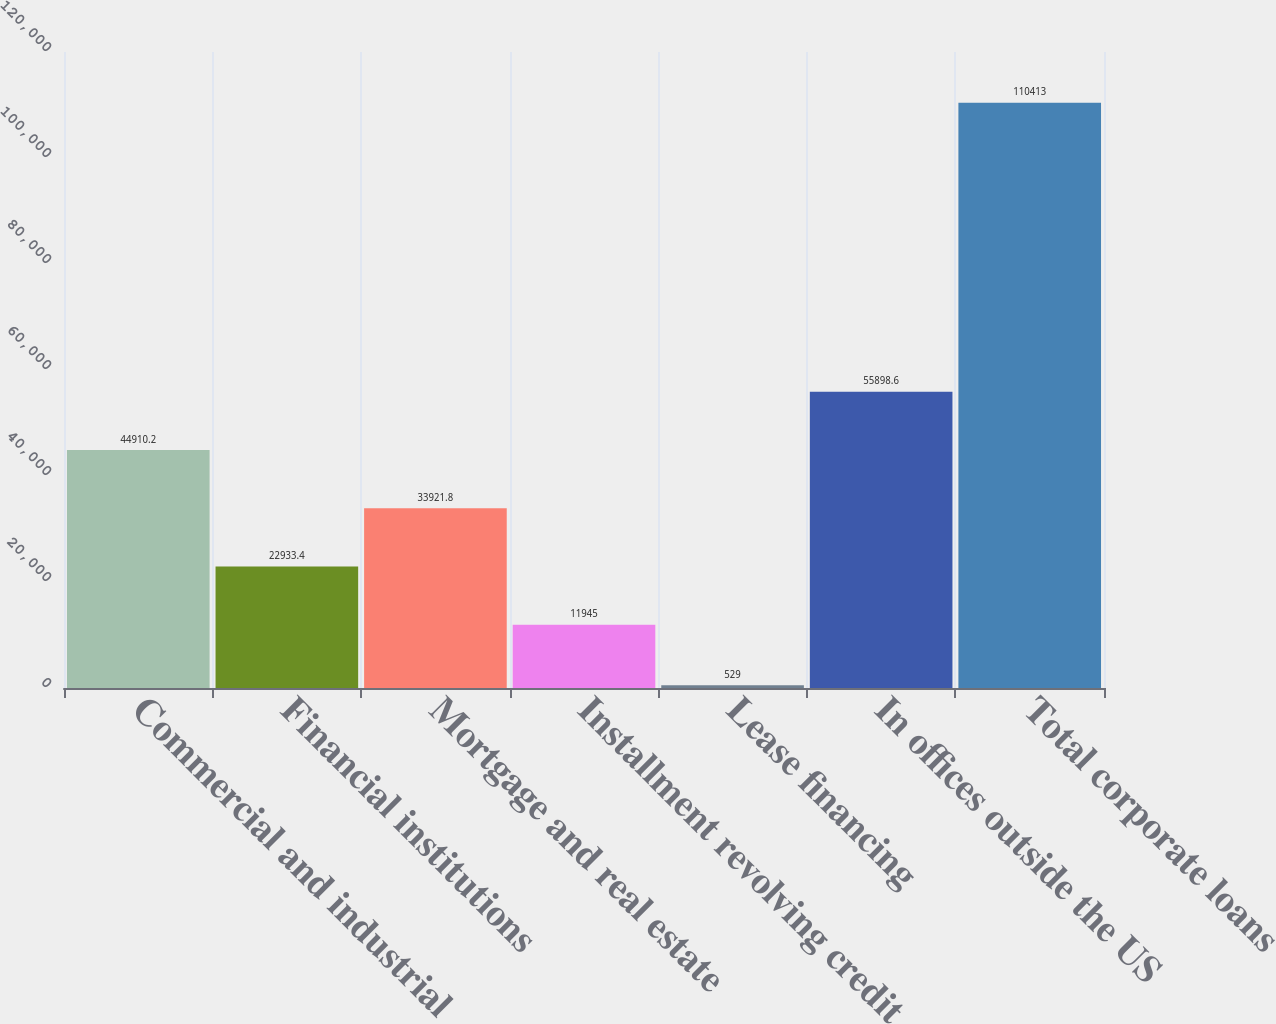<chart> <loc_0><loc_0><loc_500><loc_500><bar_chart><fcel>Commercial and industrial<fcel>Financial institutions<fcel>Mortgage and real estate<fcel>Installment revolving credit<fcel>Lease financing<fcel>In offices outside the US<fcel>Total corporate loans<nl><fcel>44910.2<fcel>22933.4<fcel>33921.8<fcel>11945<fcel>529<fcel>55898.6<fcel>110413<nl></chart> 